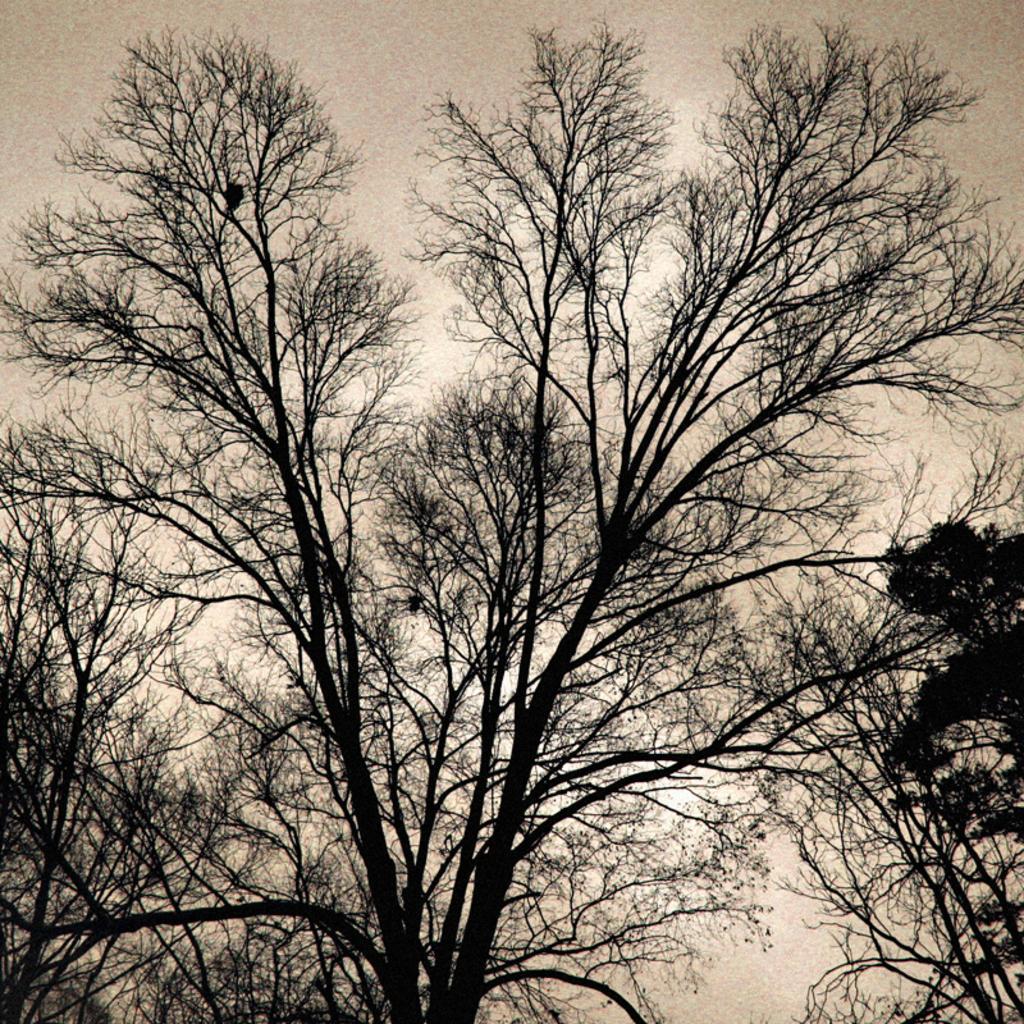Please provide a concise description of this image. In this image we can see a group of trees. On the backside we can see the sky which looks cloudy. 